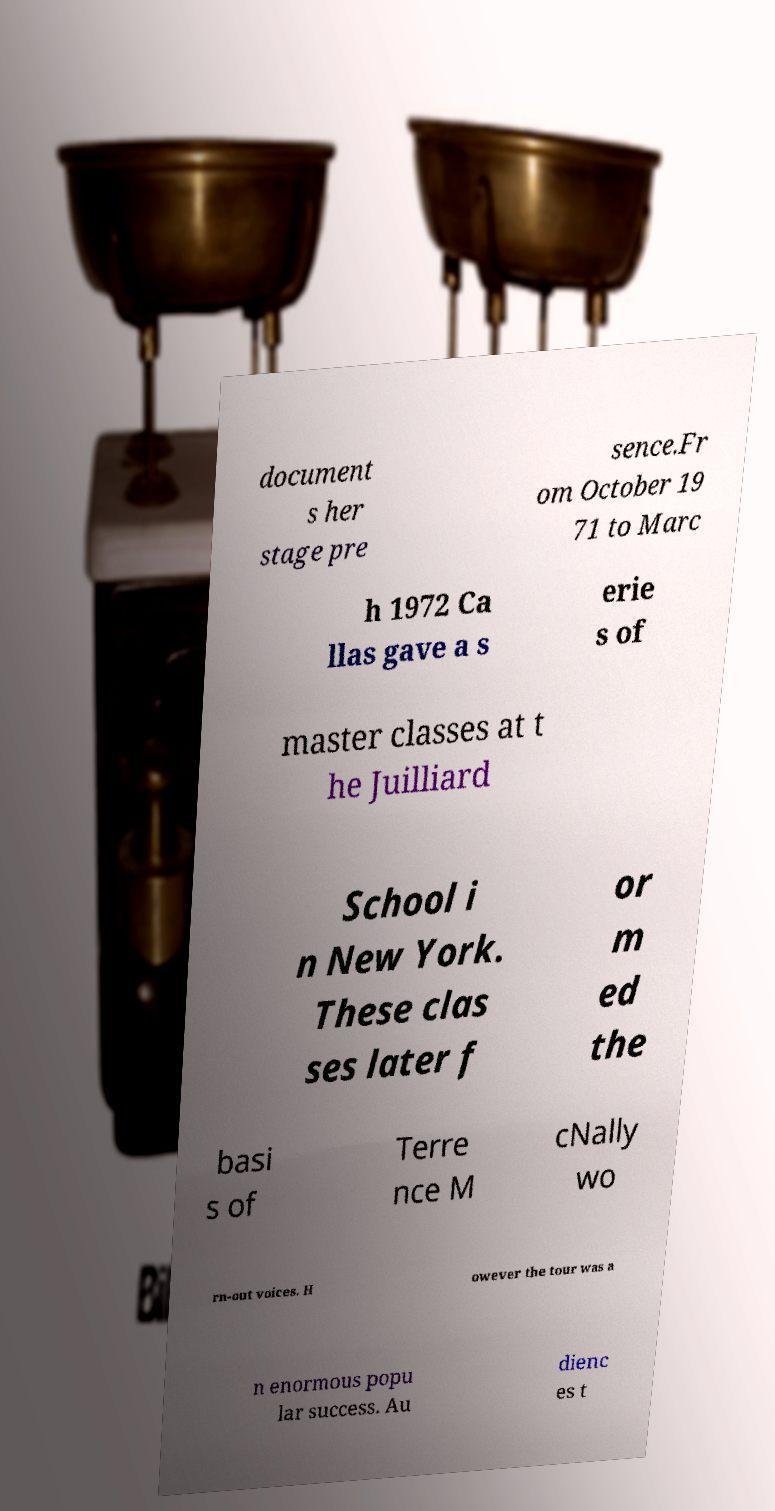There's text embedded in this image that I need extracted. Can you transcribe it verbatim? document s her stage pre sence.Fr om October 19 71 to Marc h 1972 Ca llas gave a s erie s of master classes at t he Juilliard School i n New York. These clas ses later f or m ed the basi s of Terre nce M cNally wo rn-out voices. H owever the tour was a n enormous popu lar success. Au dienc es t 